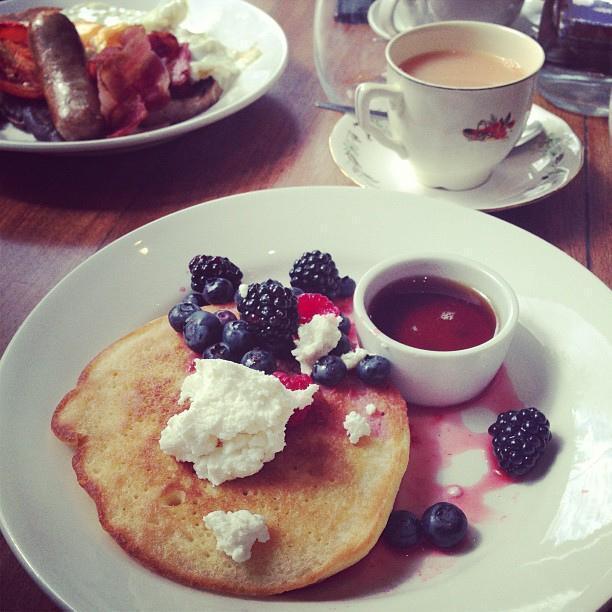How many cups are there?
Give a very brief answer. 4. How many dining tables are there?
Give a very brief answer. 2. 